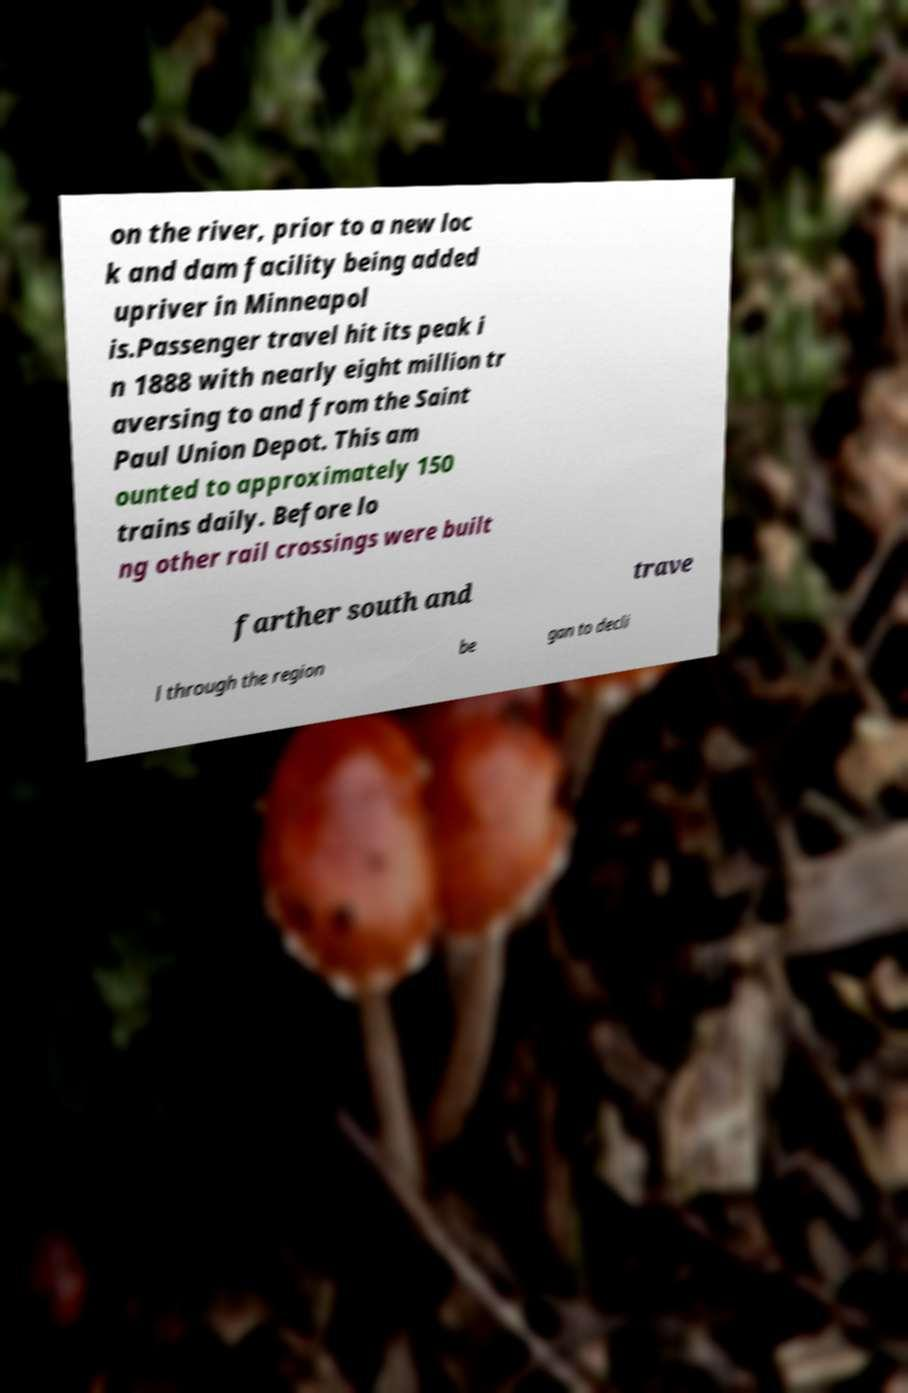For documentation purposes, I need the text within this image transcribed. Could you provide that? on the river, prior to a new loc k and dam facility being added upriver in Minneapol is.Passenger travel hit its peak i n 1888 with nearly eight million tr aversing to and from the Saint Paul Union Depot. This am ounted to approximately 150 trains daily. Before lo ng other rail crossings were built farther south and trave l through the region be gan to decli 